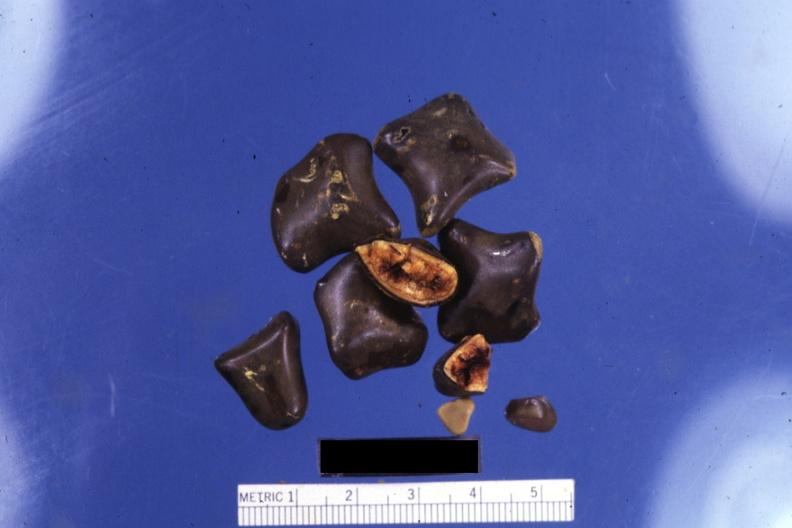s exostosis present?
Answer the question using a single word or phrase. No 